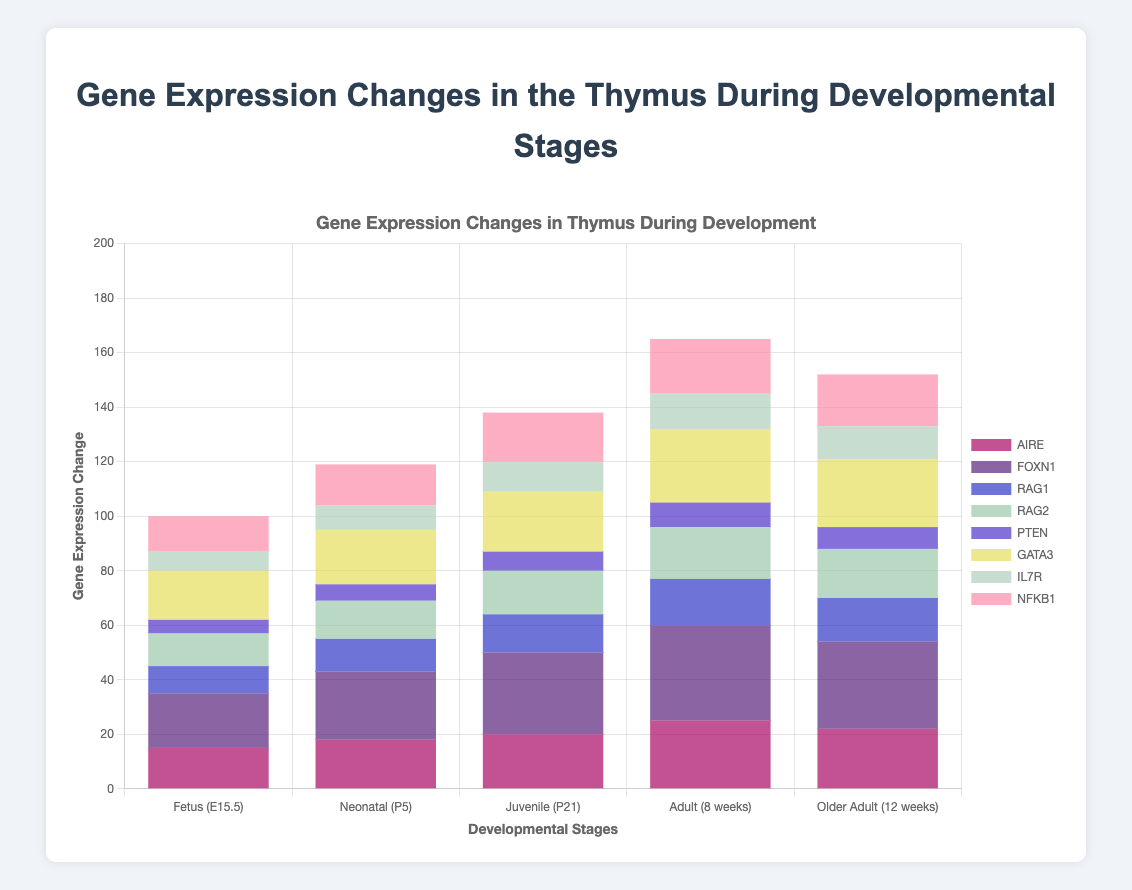Which gene shows the highest expression change in the Adult (8 weeks) stage? The stacked bar for the Adult (8 weeks) stage shows that FOXN1 has the highest portion within the bar.
Answer: FOXN1 How does the expression change of NFKB1 in the Juvenile (P21) stage compare to its change in the Fetus (E15.5) stage? The height of the NFKB1 section in the Juvenile (P21) bar is visually higher than in the Fetus (E15.5) bar. Specifically, it increased from 13 to 18.
Answer: Higher What is the cumulative gene expression change for RAG1 and RAG2 in the Neonatal (P5) stage? For the Neonatal (P5) stage, the heights for RAG1 and RAG2 are 12 and 14, respectively. Adding these gives 12 + 14.
Answer: 26 Which stage shows the lowest expression change for PTEN? By comparing the height of the PTEN sections across all developmental stages, the Fetus (E15.5) stage shows the smallest bar for PTEN.
Answer: Fetus (E15.5) Which gene expression has the most significant increase from the Neonatal (P5) to the Adult (8 weeks) stage? Comparing each gene's segments in the Neonatal (P5) and Adult (8 weeks) stages, FOXN1 shows a significant increase from 25 to 35.
Answer: FOXN1 What is the total gene expression change in the Juvenile (P21) stage? Adding up all the values for each gene in the Juvenile (P21) stage: 20 (AIRE) + 30 (FOXN1) + 14 (RAG1) + 16 (RAG2) + 7 (PTEN) + 22 (GATA3) + 11 (IL7R) + 18 (NFKB1) = 138.
Answer: 138 Is the gene expression change of IL7R higher in the Adult (8 weeks) or the Older Adult (12 weeks) stage? The comparison of IL7R segments in both stages shows a change of 13 in Adult (8 weeks) and 12 in Older Adult (12 weeks).
Answer: Adult (8 weeks) Which gene has the least variability in expression changes across all developmental stages? Observing the heights of each gene's sections across different stages, PTEN has the most consistent and least variable expression changes.
Answer: PTEN What is the average change in expression for FOXN1 across all developmental stages? Adding the FOXN1 expression changes: 20 (Fetus) + 25 (Neonatal) + 30 (Juvenile) + 35 (Adult) + 32 (Older Adult) gives a total of 142. Dividing by 5 gives an average of 142 / 5.
Answer: 28.4 